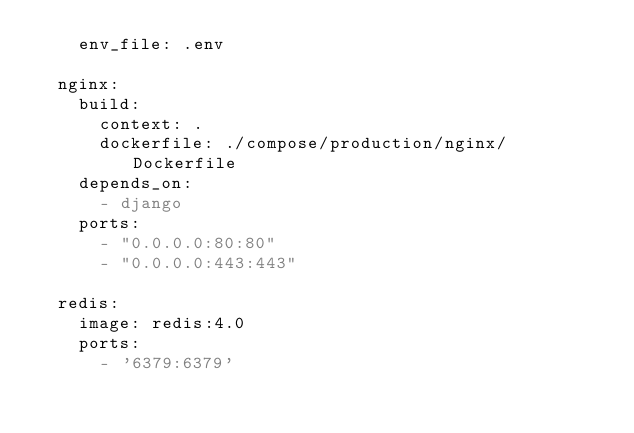Convert code to text. <code><loc_0><loc_0><loc_500><loc_500><_YAML_>    env_file: .env

  nginx:
    build:
      context: .
      dockerfile: ./compose/production/nginx/Dockerfile
    depends_on:
      - django
    ports:
      - "0.0.0.0:80:80"
      - "0.0.0.0:443:443"

  redis:
    image: redis:4.0
    ports:
      - '6379:6379'
</code> 